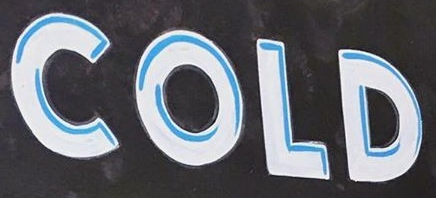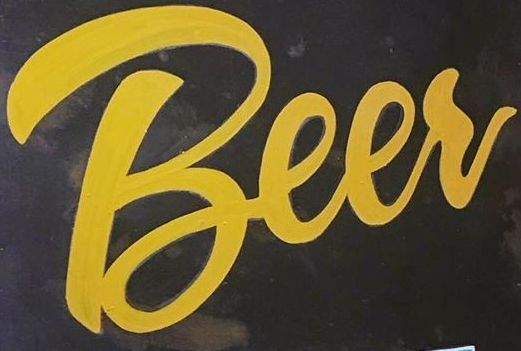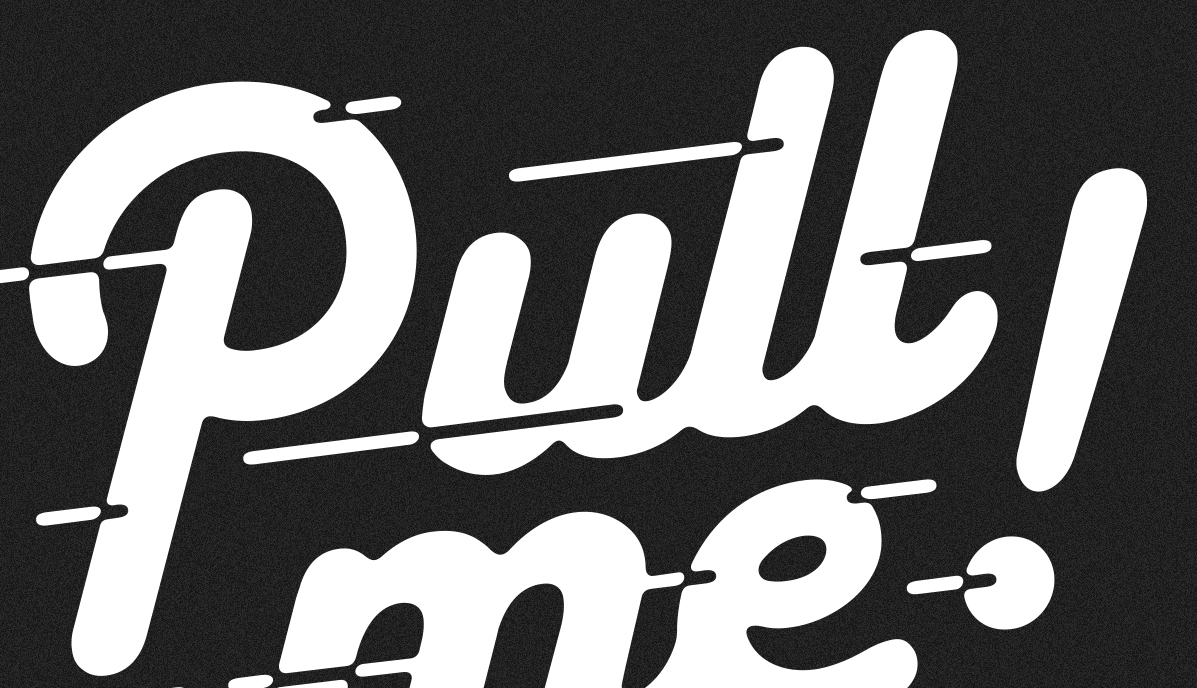Identify the words shown in these images in order, separated by a semicolon. COLD; Beer; pull! 